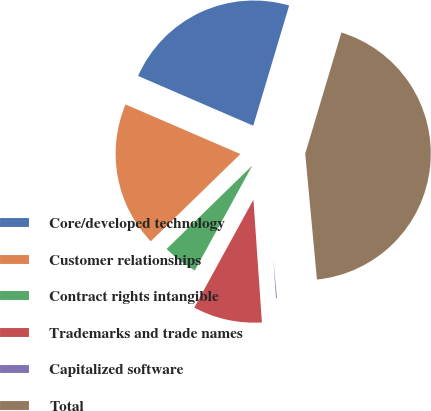<chart> <loc_0><loc_0><loc_500><loc_500><pie_chart><fcel>Core/developed technology<fcel>Customer relationships<fcel>Contract rights intangible<fcel>Trademarks and trade names<fcel>Capitalized software<fcel>Total<nl><fcel>23.13%<fcel>18.78%<fcel>4.73%<fcel>9.08%<fcel>0.38%<fcel>43.9%<nl></chart> 